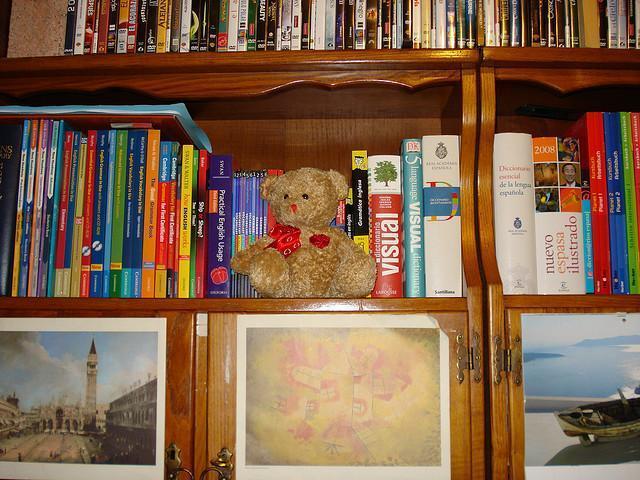How many books are there?
Give a very brief answer. 6. How many people are riding skateboards?
Give a very brief answer. 0. 